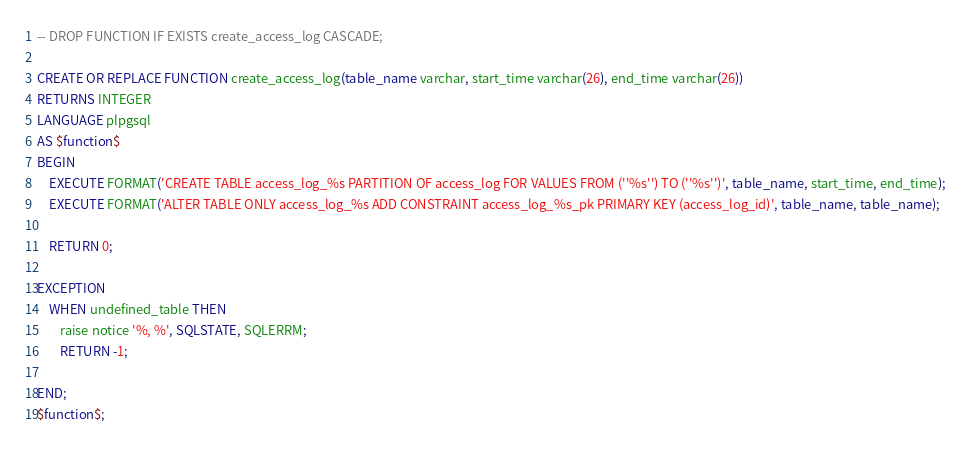<code> <loc_0><loc_0><loc_500><loc_500><_SQL_>-- DROP FUNCTION IF EXISTS create_access_log CASCADE;

CREATE OR REPLACE FUNCTION create_access_log(table_name varchar, start_time varchar(26), end_time varchar(26))
RETURNS INTEGER
LANGUAGE plpgsql
AS $function$
BEGIN
    EXECUTE FORMAT('CREATE TABLE access_log_%s PARTITION OF access_log FOR VALUES FROM (''%s'') TO (''%s'')', table_name, start_time, end_time);
    EXECUTE FORMAT('ALTER TABLE ONLY access_log_%s ADD CONSTRAINT access_log_%s_pk PRIMARY KEY (access_log_id)', table_name, table_name);

    RETURN 0;

EXCEPTION
    WHEN undefined_table THEN
        raise notice '%, %', SQLSTATE, SQLERRM;
        RETURN -1;

END;
$function$;
</code> 